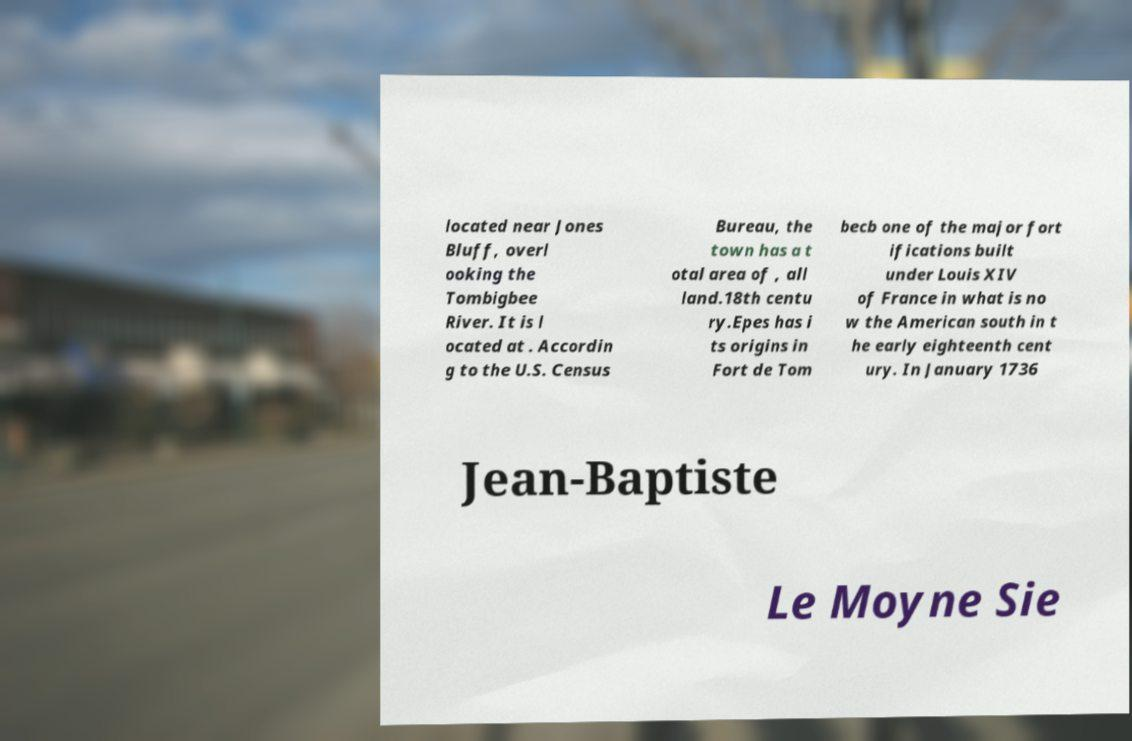I need the written content from this picture converted into text. Can you do that? located near Jones Bluff, overl ooking the Tombigbee River. It is l ocated at . Accordin g to the U.S. Census Bureau, the town has a t otal area of , all land.18th centu ry.Epes has i ts origins in Fort de Tom becb one of the major fort ifications built under Louis XIV of France in what is no w the American south in t he early eighteenth cent ury. In January 1736 Jean-Baptiste Le Moyne Sie 